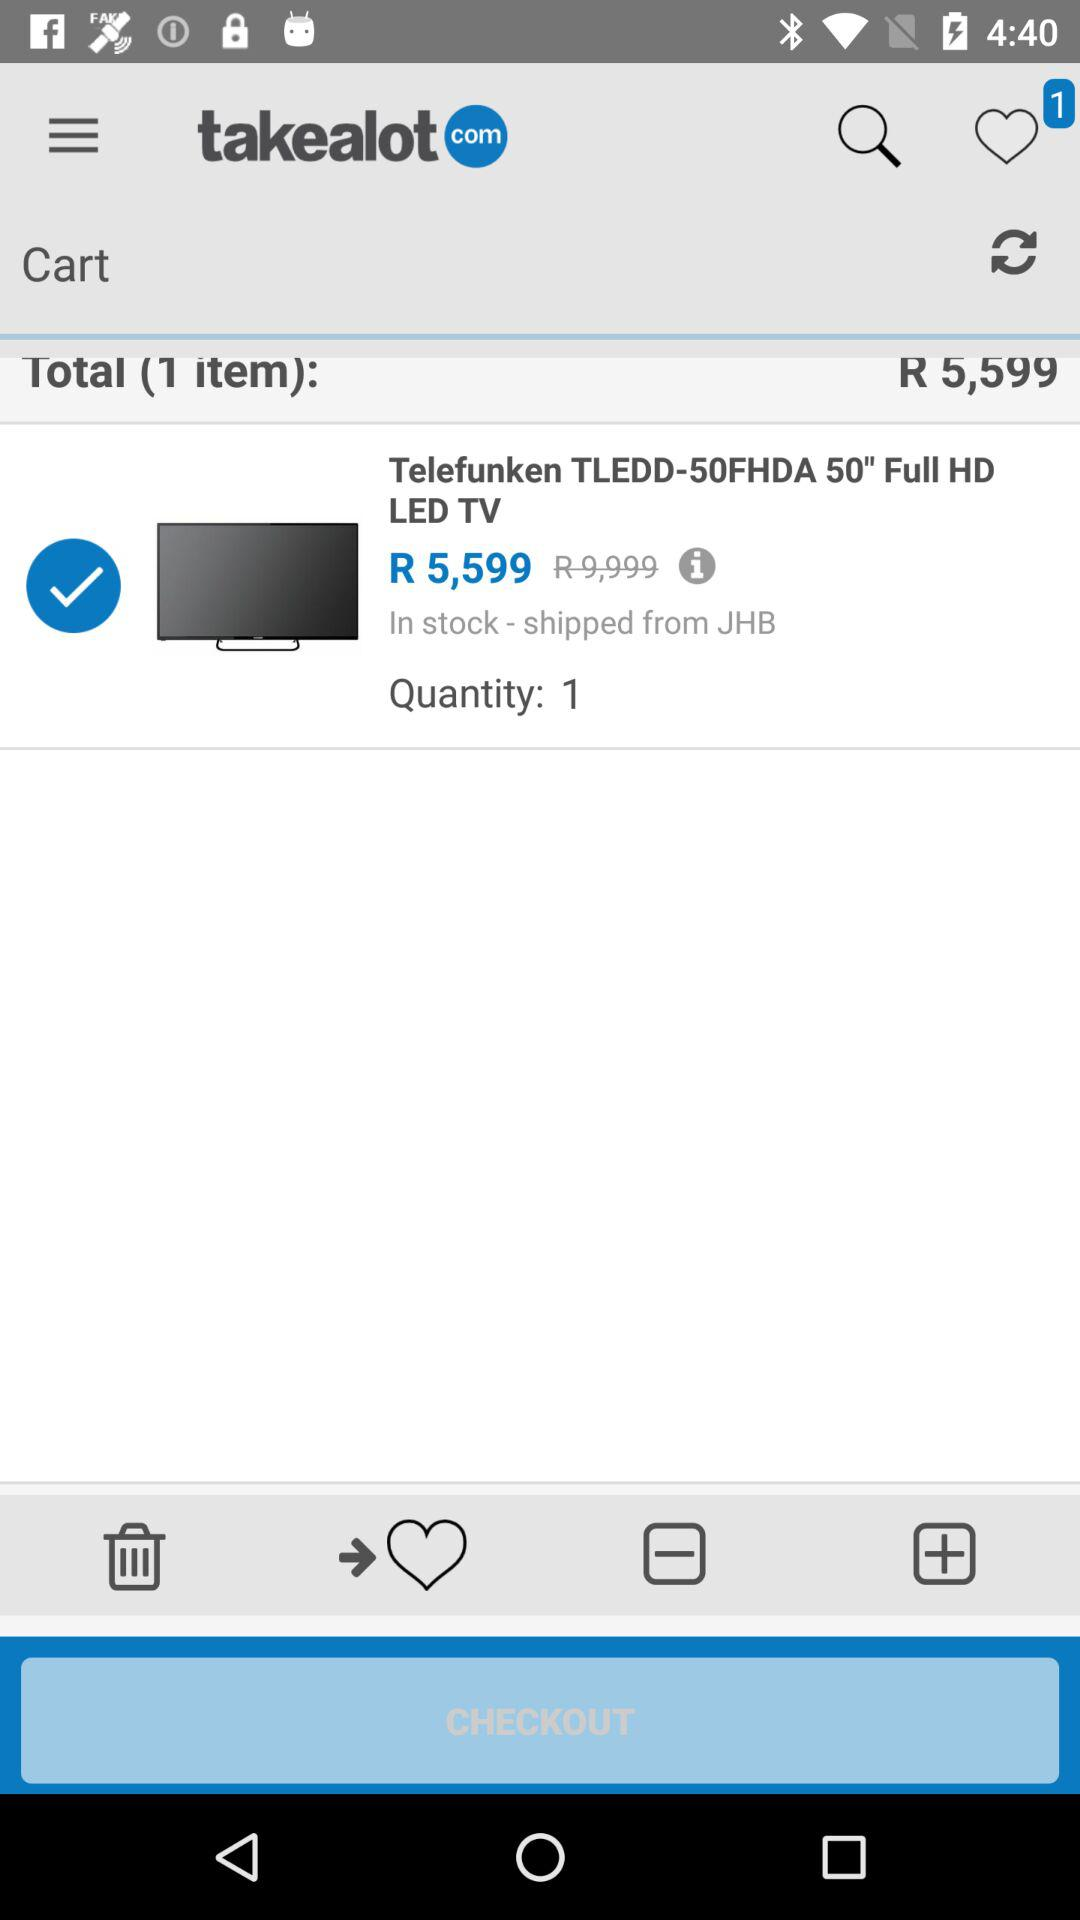What is the total amount? The total amount is R 5,599. 